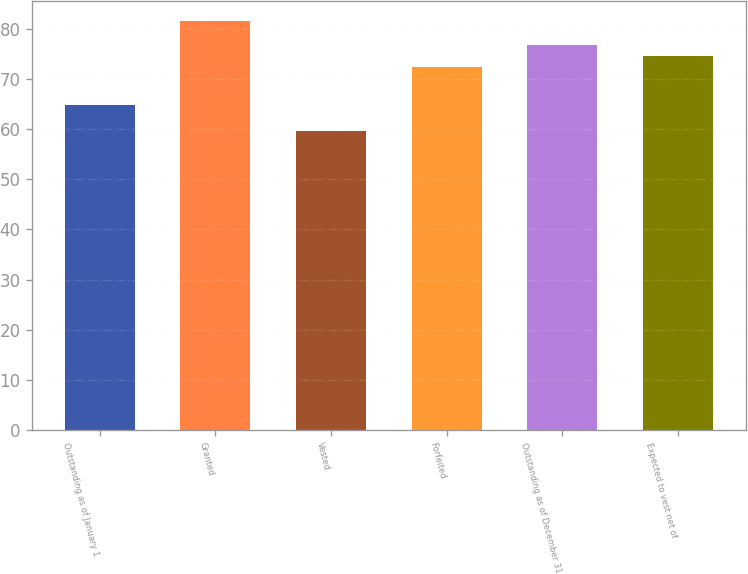Convert chart to OTSL. <chart><loc_0><loc_0><loc_500><loc_500><bar_chart><fcel>Outstanding as of January 1<fcel>Granted<fcel>Vested<fcel>Forfeited<fcel>Outstanding as of December 31<fcel>Expected to vest net of<nl><fcel>64.75<fcel>81.54<fcel>59.65<fcel>72.36<fcel>76.74<fcel>74.55<nl></chart> 